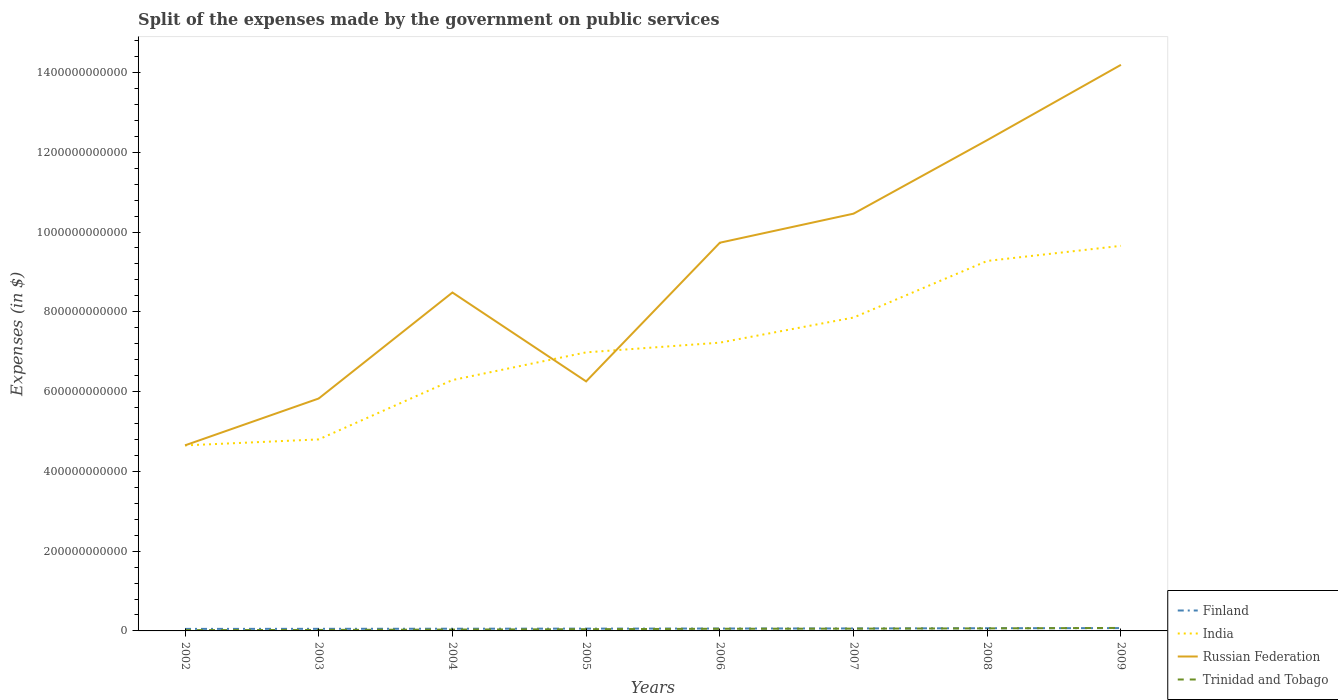Does the line corresponding to Finland intersect with the line corresponding to India?
Your response must be concise. No. Across all years, what is the maximum expenses made by the government on public services in Trinidad and Tobago?
Provide a succinct answer. 2.00e+09. What is the total expenses made by the government on public services in Trinidad and Tobago in the graph?
Your answer should be compact. -2.00e+09. What is the difference between the highest and the second highest expenses made by the government on public services in India?
Give a very brief answer. 5.00e+11. Is the expenses made by the government on public services in Trinidad and Tobago strictly greater than the expenses made by the government on public services in Russian Federation over the years?
Provide a short and direct response. Yes. How many lines are there?
Offer a terse response. 4. How many years are there in the graph?
Offer a terse response. 8. What is the difference between two consecutive major ticks on the Y-axis?
Your response must be concise. 2.00e+11. Where does the legend appear in the graph?
Offer a very short reply. Bottom right. What is the title of the graph?
Offer a terse response. Split of the expenses made by the government on public services. What is the label or title of the X-axis?
Your answer should be very brief. Years. What is the label or title of the Y-axis?
Your answer should be very brief. Expenses (in $). What is the Expenses (in $) in Finland in 2002?
Keep it short and to the point. 5.07e+09. What is the Expenses (in $) of India in 2002?
Offer a very short reply. 4.65e+11. What is the Expenses (in $) of Russian Federation in 2002?
Keep it short and to the point. 4.65e+11. What is the Expenses (in $) of Trinidad and Tobago in 2002?
Make the answer very short. 2.00e+09. What is the Expenses (in $) in Finland in 2003?
Offer a terse response. 5.26e+09. What is the Expenses (in $) in India in 2003?
Your response must be concise. 4.80e+11. What is the Expenses (in $) in Russian Federation in 2003?
Provide a succinct answer. 5.83e+11. What is the Expenses (in $) of Trinidad and Tobago in 2003?
Your response must be concise. 2.47e+09. What is the Expenses (in $) of Finland in 2004?
Keep it short and to the point. 5.52e+09. What is the Expenses (in $) of India in 2004?
Provide a succinct answer. 6.29e+11. What is the Expenses (in $) of Russian Federation in 2004?
Your response must be concise. 8.48e+11. What is the Expenses (in $) of Trinidad and Tobago in 2004?
Ensure brevity in your answer.  3.42e+09. What is the Expenses (in $) in Finland in 2005?
Give a very brief answer. 5.77e+09. What is the Expenses (in $) of India in 2005?
Offer a very short reply. 6.98e+11. What is the Expenses (in $) of Russian Federation in 2005?
Your response must be concise. 6.26e+11. What is the Expenses (in $) of Trinidad and Tobago in 2005?
Your answer should be compact. 4.34e+09. What is the Expenses (in $) in Finland in 2006?
Your answer should be very brief. 6.00e+09. What is the Expenses (in $) in India in 2006?
Your answer should be very brief. 7.23e+11. What is the Expenses (in $) of Russian Federation in 2006?
Give a very brief answer. 9.73e+11. What is the Expenses (in $) in Trinidad and Tobago in 2006?
Keep it short and to the point. 5.42e+09. What is the Expenses (in $) in Finland in 2007?
Keep it short and to the point. 6.23e+09. What is the Expenses (in $) in India in 2007?
Give a very brief answer. 7.86e+11. What is the Expenses (in $) of Russian Federation in 2007?
Make the answer very short. 1.05e+12. What is the Expenses (in $) of Trinidad and Tobago in 2007?
Your answer should be very brief. 5.72e+09. What is the Expenses (in $) in Finland in 2008?
Give a very brief answer. 6.73e+09. What is the Expenses (in $) in India in 2008?
Give a very brief answer. 9.28e+11. What is the Expenses (in $) in Russian Federation in 2008?
Ensure brevity in your answer.  1.23e+12. What is the Expenses (in $) of Trinidad and Tobago in 2008?
Provide a short and direct response. 6.37e+09. What is the Expenses (in $) in Finland in 2009?
Offer a very short reply. 7.08e+09. What is the Expenses (in $) in India in 2009?
Give a very brief answer. 9.65e+11. What is the Expenses (in $) of Russian Federation in 2009?
Your answer should be compact. 1.42e+12. What is the Expenses (in $) in Trinidad and Tobago in 2009?
Provide a succinct answer. 7.48e+09. Across all years, what is the maximum Expenses (in $) of Finland?
Provide a succinct answer. 7.08e+09. Across all years, what is the maximum Expenses (in $) in India?
Offer a very short reply. 9.65e+11. Across all years, what is the maximum Expenses (in $) of Russian Federation?
Your answer should be compact. 1.42e+12. Across all years, what is the maximum Expenses (in $) in Trinidad and Tobago?
Make the answer very short. 7.48e+09. Across all years, what is the minimum Expenses (in $) in Finland?
Offer a very short reply. 5.07e+09. Across all years, what is the minimum Expenses (in $) of India?
Ensure brevity in your answer.  4.65e+11. Across all years, what is the minimum Expenses (in $) of Russian Federation?
Offer a very short reply. 4.65e+11. Across all years, what is the minimum Expenses (in $) in Trinidad and Tobago?
Offer a terse response. 2.00e+09. What is the total Expenses (in $) of Finland in the graph?
Keep it short and to the point. 4.77e+1. What is the total Expenses (in $) in India in the graph?
Your answer should be compact. 5.67e+12. What is the total Expenses (in $) of Russian Federation in the graph?
Offer a very short reply. 7.19e+12. What is the total Expenses (in $) in Trinidad and Tobago in the graph?
Your answer should be compact. 3.72e+1. What is the difference between the Expenses (in $) in Finland in 2002 and that in 2003?
Give a very brief answer. -1.97e+08. What is the difference between the Expenses (in $) of India in 2002 and that in 2003?
Your answer should be very brief. -1.50e+1. What is the difference between the Expenses (in $) of Russian Federation in 2002 and that in 2003?
Offer a terse response. -1.17e+11. What is the difference between the Expenses (in $) of Trinidad and Tobago in 2002 and that in 2003?
Your response must be concise. -4.67e+08. What is the difference between the Expenses (in $) in Finland in 2002 and that in 2004?
Give a very brief answer. -4.53e+08. What is the difference between the Expenses (in $) in India in 2002 and that in 2004?
Your answer should be very brief. -1.64e+11. What is the difference between the Expenses (in $) of Russian Federation in 2002 and that in 2004?
Offer a very short reply. -3.83e+11. What is the difference between the Expenses (in $) of Trinidad and Tobago in 2002 and that in 2004?
Keep it short and to the point. -1.41e+09. What is the difference between the Expenses (in $) of Finland in 2002 and that in 2005?
Your response must be concise. -7.02e+08. What is the difference between the Expenses (in $) in India in 2002 and that in 2005?
Provide a succinct answer. -2.33e+11. What is the difference between the Expenses (in $) in Russian Federation in 2002 and that in 2005?
Give a very brief answer. -1.60e+11. What is the difference between the Expenses (in $) in Trinidad and Tobago in 2002 and that in 2005?
Offer a terse response. -2.33e+09. What is the difference between the Expenses (in $) of Finland in 2002 and that in 2006?
Keep it short and to the point. -9.37e+08. What is the difference between the Expenses (in $) in India in 2002 and that in 2006?
Keep it short and to the point. -2.58e+11. What is the difference between the Expenses (in $) of Russian Federation in 2002 and that in 2006?
Keep it short and to the point. -5.08e+11. What is the difference between the Expenses (in $) in Trinidad and Tobago in 2002 and that in 2006?
Ensure brevity in your answer.  -3.42e+09. What is the difference between the Expenses (in $) in Finland in 2002 and that in 2007?
Offer a very short reply. -1.16e+09. What is the difference between the Expenses (in $) of India in 2002 and that in 2007?
Ensure brevity in your answer.  -3.21e+11. What is the difference between the Expenses (in $) of Russian Federation in 2002 and that in 2007?
Provide a short and direct response. -5.81e+11. What is the difference between the Expenses (in $) of Trinidad and Tobago in 2002 and that in 2007?
Make the answer very short. -3.72e+09. What is the difference between the Expenses (in $) in Finland in 2002 and that in 2008?
Your answer should be compact. -1.67e+09. What is the difference between the Expenses (in $) in India in 2002 and that in 2008?
Provide a short and direct response. -4.62e+11. What is the difference between the Expenses (in $) in Russian Federation in 2002 and that in 2008?
Make the answer very short. -7.65e+11. What is the difference between the Expenses (in $) in Trinidad and Tobago in 2002 and that in 2008?
Your answer should be very brief. -4.36e+09. What is the difference between the Expenses (in $) in Finland in 2002 and that in 2009?
Your response must be concise. -2.01e+09. What is the difference between the Expenses (in $) in India in 2002 and that in 2009?
Your answer should be compact. -5.00e+11. What is the difference between the Expenses (in $) of Russian Federation in 2002 and that in 2009?
Provide a succinct answer. -9.54e+11. What is the difference between the Expenses (in $) in Trinidad and Tobago in 2002 and that in 2009?
Your answer should be compact. -5.48e+09. What is the difference between the Expenses (in $) of Finland in 2003 and that in 2004?
Your answer should be very brief. -2.56e+08. What is the difference between the Expenses (in $) of India in 2003 and that in 2004?
Give a very brief answer. -1.49e+11. What is the difference between the Expenses (in $) in Russian Federation in 2003 and that in 2004?
Make the answer very short. -2.66e+11. What is the difference between the Expenses (in $) of Trinidad and Tobago in 2003 and that in 2004?
Provide a succinct answer. -9.46e+08. What is the difference between the Expenses (in $) of Finland in 2003 and that in 2005?
Make the answer very short. -5.05e+08. What is the difference between the Expenses (in $) in India in 2003 and that in 2005?
Offer a terse response. -2.18e+11. What is the difference between the Expenses (in $) of Russian Federation in 2003 and that in 2005?
Your answer should be very brief. -4.29e+1. What is the difference between the Expenses (in $) of Trinidad and Tobago in 2003 and that in 2005?
Ensure brevity in your answer.  -1.87e+09. What is the difference between the Expenses (in $) in Finland in 2003 and that in 2006?
Offer a very short reply. -7.40e+08. What is the difference between the Expenses (in $) in India in 2003 and that in 2006?
Your answer should be compact. -2.43e+11. What is the difference between the Expenses (in $) in Russian Federation in 2003 and that in 2006?
Offer a terse response. -3.91e+11. What is the difference between the Expenses (in $) in Trinidad and Tobago in 2003 and that in 2006?
Provide a succinct answer. -2.95e+09. What is the difference between the Expenses (in $) of Finland in 2003 and that in 2007?
Your answer should be very brief. -9.62e+08. What is the difference between the Expenses (in $) of India in 2003 and that in 2007?
Give a very brief answer. -3.05e+11. What is the difference between the Expenses (in $) in Russian Federation in 2003 and that in 2007?
Ensure brevity in your answer.  -4.63e+11. What is the difference between the Expenses (in $) in Trinidad and Tobago in 2003 and that in 2007?
Your answer should be compact. -3.25e+09. What is the difference between the Expenses (in $) of Finland in 2003 and that in 2008?
Offer a terse response. -1.47e+09. What is the difference between the Expenses (in $) in India in 2003 and that in 2008?
Your answer should be very brief. -4.47e+11. What is the difference between the Expenses (in $) of Russian Federation in 2003 and that in 2008?
Your answer should be very brief. -6.48e+11. What is the difference between the Expenses (in $) of Trinidad and Tobago in 2003 and that in 2008?
Ensure brevity in your answer.  -3.90e+09. What is the difference between the Expenses (in $) of Finland in 2003 and that in 2009?
Your answer should be very brief. -1.81e+09. What is the difference between the Expenses (in $) of India in 2003 and that in 2009?
Your response must be concise. -4.85e+11. What is the difference between the Expenses (in $) of Russian Federation in 2003 and that in 2009?
Ensure brevity in your answer.  -8.36e+11. What is the difference between the Expenses (in $) of Trinidad and Tobago in 2003 and that in 2009?
Your answer should be compact. -5.01e+09. What is the difference between the Expenses (in $) in Finland in 2004 and that in 2005?
Give a very brief answer. -2.49e+08. What is the difference between the Expenses (in $) of India in 2004 and that in 2005?
Your response must be concise. -6.94e+1. What is the difference between the Expenses (in $) of Russian Federation in 2004 and that in 2005?
Offer a terse response. 2.23e+11. What is the difference between the Expenses (in $) of Trinidad and Tobago in 2004 and that in 2005?
Provide a short and direct response. -9.19e+08. What is the difference between the Expenses (in $) in Finland in 2004 and that in 2006?
Your response must be concise. -4.84e+08. What is the difference between the Expenses (in $) of India in 2004 and that in 2006?
Make the answer very short. -9.38e+1. What is the difference between the Expenses (in $) of Russian Federation in 2004 and that in 2006?
Your answer should be compact. -1.25e+11. What is the difference between the Expenses (in $) of Trinidad and Tobago in 2004 and that in 2006?
Your answer should be compact. -2.00e+09. What is the difference between the Expenses (in $) in Finland in 2004 and that in 2007?
Ensure brevity in your answer.  -7.06e+08. What is the difference between the Expenses (in $) of India in 2004 and that in 2007?
Your answer should be compact. -1.57e+11. What is the difference between the Expenses (in $) of Russian Federation in 2004 and that in 2007?
Your answer should be compact. -1.98e+11. What is the difference between the Expenses (in $) in Trinidad and Tobago in 2004 and that in 2007?
Give a very brief answer. -2.30e+09. What is the difference between the Expenses (in $) in Finland in 2004 and that in 2008?
Provide a succinct answer. -1.21e+09. What is the difference between the Expenses (in $) in India in 2004 and that in 2008?
Give a very brief answer. -2.99e+11. What is the difference between the Expenses (in $) in Russian Federation in 2004 and that in 2008?
Ensure brevity in your answer.  -3.82e+11. What is the difference between the Expenses (in $) in Trinidad and Tobago in 2004 and that in 2008?
Your answer should be very brief. -2.95e+09. What is the difference between the Expenses (in $) in Finland in 2004 and that in 2009?
Ensure brevity in your answer.  -1.56e+09. What is the difference between the Expenses (in $) of India in 2004 and that in 2009?
Your answer should be compact. -3.36e+11. What is the difference between the Expenses (in $) in Russian Federation in 2004 and that in 2009?
Your response must be concise. -5.71e+11. What is the difference between the Expenses (in $) in Trinidad and Tobago in 2004 and that in 2009?
Your answer should be very brief. -4.07e+09. What is the difference between the Expenses (in $) of Finland in 2005 and that in 2006?
Give a very brief answer. -2.35e+08. What is the difference between the Expenses (in $) of India in 2005 and that in 2006?
Your answer should be very brief. -2.43e+1. What is the difference between the Expenses (in $) of Russian Federation in 2005 and that in 2006?
Keep it short and to the point. -3.48e+11. What is the difference between the Expenses (in $) of Trinidad and Tobago in 2005 and that in 2006?
Give a very brief answer. -1.08e+09. What is the difference between the Expenses (in $) in Finland in 2005 and that in 2007?
Provide a succinct answer. -4.57e+08. What is the difference between the Expenses (in $) in India in 2005 and that in 2007?
Make the answer very short. -8.73e+1. What is the difference between the Expenses (in $) of Russian Federation in 2005 and that in 2007?
Your response must be concise. -4.20e+11. What is the difference between the Expenses (in $) in Trinidad and Tobago in 2005 and that in 2007?
Keep it short and to the point. -1.38e+09. What is the difference between the Expenses (in $) of Finland in 2005 and that in 2008?
Ensure brevity in your answer.  -9.64e+08. What is the difference between the Expenses (in $) in India in 2005 and that in 2008?
Your answer should be very brief. -2.29e+11. What is the difference between the Expenses (in $) in Russian Federation in 2005 and that in 2008?
Offer a terse response. -6.05e+11. What is the difference between the Expenses (in $) of Trinidad and Tobago in 2005 and that in 2008?
Your answer should be compact. -2.03e+09. What is the difference between the Expenses (in $) of Finland in 2005 and that in 2009?
Give a very brief answer. -1.31e+09. What is the difference between the Expenses (in $) in India in 2005 and that in 2009?
Provide a succinct answer. -2.67e+11. What is the difference between the Expenses (in $) of Russian Federation in 2005 and that in 2009?
Offer a very short reply. -7.94e+11. What is the difference between the Expenses (in $) of Trinidad and Tobago in 2005 and that in 2009?
Your answer should be very brief. -3.15e+09. What is the difference between the Expenses (in $) of Finland in 2006 and that in 2007?
Make the answer very short. -2.22e+08. What is the difference between the Expenses (in $) in India in 2006 and that in 2007?
Your answer should be compact. -6.29e+1. What is the difference between the Expenses (in $) of Russian Federation in 2006 and that in 2007?
Your answer should be very brief. -7.28e+1. What is the difference between the Expenses (in $) in Trinidad and Tobago in 2006 and that in 2007?
Provide a succinct answer. -3.00e+08. What is the difference between the Expenses (in $) in Finland in 2006 and that in 2008?
Give a very brief answer. -7.29e+08. What is the difference between the Expenses (in $) in India in 2006 and that in 2008?
Provide a succinct answer. -2.05e+11. What is the difference between the Expenses (in $) of Russian Federation in 2006 and that in 2008?
Offer a terse response. -2.57e+11. What is the difference between the Expenses (in $) of Trinidad and Tobago in 2006 and that in 2008?
Provide a succinct answer. -9.46e+08. What is the difference between the Expenses (in $) of Finland in 2006 and that in 2009?
Give a very brief answer. -1.07e+09. What is the difference between the Expenses (in $) of India in 2006 and that in 2009?
Make the answer very short. -2.43e+11. What is the difference between the Expenses (in $) in Russian Federation in 2006 and that in 2009?
Make the answer very short. -4.46e+11. What is the difference between the Expenses (in $) of Trinidad and Tobago in 2006 and that in 2009?
Your answer should be compact. -2.06e+09. What is the difference between the Expenses (in $) in Finland in 2007 and that in 2008?
Give a very brief answer. -5.07e+08. What is the difference between the Expenses (in $) in India in 2007 and that in 2008?
Offer a very short reply. -1.42e+11. What is the difference between the Expenses (in $) in Russian Federation in 2007 and that in 2008?
Provide a succinct answer. -1.84e+11. What is the difference between the Expenses (in $) in Trinidad and Tobago in 2007 and that in 2008?
Keep it short and to the point. -6.47e+08. What is the difference between the Expenses (in $) of Finland in 2007 and that in 2009?
Provide a succinct answer. -8.49e+08. What is the difference between the Expenses (in $) in India in 2007 and that in 2009?
Give a very brief answer. -1.80e+11. What is the difference between the Expenses (in $) of Russian Federation in 2007 and that in 2009?
Your answer should be very brief. -3.73e+11. What is the difference between the Expenses (in $) of Trinidad and Tobago in 2007 and that in 2009?
Keep it short and to the point. -1.76e+09. What is the difference between the Expenses (in $) in Finland in 2008 and that in 2009?
Provide a short and direct response. -3.42e+08. What is the difference between the Expenses (in $) in India in 2008 and that in 2009?
Give a very brief answer. -3.78e+1. What is the difference between the Expenses (in $) of Russian Federation in 2008 and that in 2009?
Offer a very short reply. -1.89e+11. What is the difference between the Expenses (in $) of Trinidad and Tobago in 2008 and that in 2009?
Make the answer very short. -1.12e+09. What is the difference between the Expenses (in $) of Finland in 2002 and the Expenses (in $) of India in 2003?
Provide a short and direct response. -4.75e+11. What is the difference between the Expenses (in $) of Finland in 2002 and the Expenses (in $) of Russian Federation in 2003?
Provide a short and direct response. -5.78e+11. What is the difference between the Expenses (in $) of Finland in 2002 and the Expenses (in $) of Trinidad and Tobago in 2003?
Offer a terse response. 2.60e+09. What is the difference between the Expenses (in $) of India in 2002 and the Expenses (in $) of Russian Federation in 2003?
Offer a terse response. -1.18e+11. What is the difference between the Expenses (in $) of India in 2002 and the Expenses (in $) of Trinidad and Tobago in 2003?
Ensure brevity in your answer.  4.63e+11. What is the difference between the Expenses (in $) in Russian Federation in 2002 and the Expenses (in $) in Trinidad and Tobago in 2003?
Ensure brevity in your answer.  4.63e+11. What is the difference between the Expenses (in $) in Finland in 2002 and the Expenses (in $) in India in 2004?
Offer a terse response. -6.24e+11. What is the difference between the Expenses (in $) of Finland in 2002 and the Expenses (in $) of Russian Federation in 2004?
Provide a short and direct response. -8.43e+11. What is the difference between the Expenses (in $) in Finland in 2002 and the Expenses (in $) in Trinidad and Tobago in 2004?
Keep it short and to the point. 1.65e+09. What is the difference between the Expenses (in $) of India in 2002 and the Expenses (in $) of Russian Federation in 2004?
Offer a terse response. -3.83e+11. What is the difference between the Expenses (in $) in India in 2002 and the Expenses (in $) in Trinidad and Tobago in 2004?
Your answer should be compact. 4.62e+11. What is the difference between the Expenses (in $) of Russian Federation in 2002 and the Expenses (in $) of Trinidad and Tobago in 2004?
Provide a succinct answer. 4.62e+11. What is the difference between the Expenses (in $) in Finland in 2002 and the Expenses (in $) in India in 2005?
Provide a succinct answer. -6.93e+11. What is the difference between the Expenses (in $) in Finland in 2002 and the Expenses (in $) in Russian Federation in 2005?
Your response must be concise. -6.20e+11. What is the difference between the Expenses (in $) in Finland in 2002 and the Expenses (in $) in Trinidad and Tobago in 2005?
Provide a short and direct response. 7.31e+08. What is the difference between the Expenses (in $) of India in 2002 and the Expenses (in $) of Russian Federation in 2005?
Offer a very short reply. -1.60e+11. What is the difference between the Expenses (in $) in India in 2002 and the Expenses (in $) in Trinidad and Tobago in 2005?
Provide a succinct answer. 4.61e+11. What is the difference between the Expenses (in $) in Russian Federation in 2002 and the Expenses (in $) in Trinidad and Tobago in 2005?
Ensure brevity in your answer.  4.61e+11. What is the difference between the Expenses (in $) in Finland in 2002 and the Expenses (in $) in India in 2006?
Give a very brief answer. -7.18e+11. What is the difference between the Expenses (in $) of Finland in 2002 and the Expenses (in $) of Russian Federation in 2006?
Offer a terse response. -9.68e+11. What is the difference between the Expenses (in $) of Finland in 2002 and the Expenses (in $) of Trinidad and Tobago in 2006?
Give a very brief answer. -3.52e+08. What is the difference between the Expenses (in $) of India in 2002 and the Expenses (in $) of Russian Federation in 2006?
Provide a succinct answer. -5.08e+11. What is the difference between the Expenses (in $) of India in 2002 and the Expenses (in $) of Trinidad and Tobago in 2006?
Offer a terse response. 4.60e+11. What is the difference between the Expenses (in $) in Russian Federation in 2002 and the Expenses (in $) in Trinidad and Tobago in 2006?
Make the answer very short. 4.60e+11. What is the difference between the Expenses (in $) of Finland in 2002 and the Expenses (in $) of India in 2007?
Offer a terse response. -7.81e+11. What is the difference between the Expenses (in $) in Finland in 2002 and the Expenses (in $) in Russian Federation in 2007?
Give a very brief answer. -1.04e+12. What is the difference between the Expenses (in $) of Finland in 2002 and the Expenses (in $) of Trinidad and Tobago in 2007?
Your response must be concise. -6.52e+08. What is the difference between the Expenses (in $) in India in 2002 and the Expenses (in $) in Russian Federation in 2007?
Your answer should be very brief. -5.81e+11. What is the difference between the Expenses (in $) in India in 2002 and the Expenses (in $) in Trinidad and Tobago in 2007?
Make the answer very short. 4.59e+11. What is the difference between the Expenses (in $) in Russian Federation in 2002 and the Expenses (in $) in Trinidad and Tobago in 2007?
Make the answer very short. 4.59e+11. What is the difference between the Expenses (in $) of Finland in 2002 and the Expenses (in $) of India in 2008?
Make the answer very short. -9.22e+11. What is the difference between the Expenses (in $) of Finland in 2002 and the Expenses (in $) of Russian Federation in 2008?
Offer a very short reply. -1.23e+12. What is the difference between the Expenses (in $) of Finland in 2002 and the Expenses (in $) of Trinidad and Tobago in 2008?
Ensure brevity in your answer.  -1.30e+09. What is the difference between the Expenses (in $) in India in 2002 and the Expenses (in $) in Russian Federation in 2008?
Keep it short and to the point. -7.65e+11. What is the difference between the Expenses (in $) of India in 2002 and the Expenses (in $) of Trinidad and Tobago in 2008?
Give a very brief answer. 4.59e+11. What is the difference between the Expenses (in $) of Russian Federation in 2002 and the Expenses (in $) of Trinidad and Tobago in 2008?
Give a very brief answer. 4.59e+11. What is the difference between the Expenses (in $) of Finland in 2002 and the Expenses (in $) of India in 2009?
Your response must be concise. -9.60e+11. What is the difference between the Expenses (in $) in Finland in 2002 and the Expenses (in $) in Russian Federation in 2009?
Provide a succinct answer. -1.41e+12. What is the difference between the Expenses (in $) in Finland in 2002 and the Expenses (in $) in Trinidad and Tobago in 2009?
Offer a very short reply. -2.42e+09. What is the difference between the Expenses (in $) in India in 2002 and the Expenses (in $) in Russian Federation in 2009?
Your answer should be very brief. -9.54e+11. What is the difference between the Expenses (in $) in India in 2002 and the Expenses (in $) in Trinidad and Tobago in 2009?
Your answer should be very brief. 4.58e+11. What is the difference between the Expenses (in $) of Russian Federation in 2002 and the Expenses (in $) of Trinidad and Tobago in 2009?
Offer a very short reply. 4.58e+11. What is the difference between the Expenses (in $) of Finland in 2003 and the Expenses (in $) of India in 2004?
Your answer should be very brief. -6.24e+11. What is the difference between the Expenses (in $) of Finland in 2003 and the Expenses (in $) of Russian Federation in 2004?
Your answer should be very brief. -8.43e+11. What is the difference between the Expenses (in $) of Finland in 2003 and the Expenses (in $) of Trinidad and Tobago in 2004?
Ensure brevity in your answer.  1.85e+09. What is the difference between the Expenses (in $) of India in 2003 and the Expenses (in $) of Russian Federation in 2004?
Your response must be concise. -3.68e+11. What is the difference between the Expenses (in $) in India in 2003 and the Expenses (in $) in Trinidad and Tobago in 2004?
Your answer should be very brief. 4.77e+11. What is the difference between the Expenses (in $) of Russian Federation in 2003 and the Expenses (in $) of Trinidad and Tobago in 2004?
Offer a very short reply. 5.79e+11. What is the difference between the Expenses (in $) of Finland in 2003 and the Expenses (in $) of India in 2005?
Give a very brief answer. -6.93e+11. What is the difference between the Expenses (in $) of Finland in 2003 and the Expenses (in $) of Russian Federation in 2005?
Ensure brevity in your answer.  -6.20e+11. What is the difference between the Expenses (in $) in Finland in 2003 and the Expenses (in $) in Trinidad and Tobago in 2005?
Offer a terse response. 9.28e+08. What is the difference between the Expenses (in $) of India in 2003 and the Expenses (in $) of Russian Federation in 2005?
Provide a short and direct response. -1.45e+11. What is the difference between the Expenses (in $) of India in 2003 and the Expenses (in $) of Trinidad and Tobago in 2005?
Offer a terse response. 4.76e+11. What is the difference between the Expenses (in $) of Russian Federation in 2003 and the Expenses (in $) of Trinidad and Tobago in 2005?
Give a very brief answer. 5.78e+11. What is the difference between the Expenses (in $) of Finland in 2003 and the Expenses (in $) of India in 2006?
Ensure brevity in your answer.  -7.17e+11. What is the difference between the Expenses (in $) of Finland in 2003 and the Expenses (in $) of Russian Federation in 2006?
Offer a terse response. -9.68e+11. What is the difference between the Expenses (in $) in Finland in 2003 and the Expenses (in $) in Trinidad and Tobago in 2006?
Offer a terse response. -1.56e+08. What is the difference between the Expenses (in $) in India in 2003 and the Expenses (in $) in Russian Federation in 2006?
Ensure brevity in your answer.  -4.93e+11. What is the difference between the Expenses (in $) of India in 2003 and the Expenses (in $) of Trinidad and Tobago in 2006?
Offer a very short reply. 4.75e+11. What is the difference between the Expenses (in $) of Russian Federation in 2003 and the Expenses (in $) of Trinidad and Tobago in 2006?
Your answer should be compact. 5.77e+11. What is the difference between the Expenses (in $) of Finland in 2003 and the Expenses (in $) of India in 2007?
Ensure brevity in your answer.  -7.80e+11. What is the difference between the Expenses (in $) of Finland in 2003 and the Expenses (in $) of Russian Federation in 2007?
Offer a very short reply. -1.04e+12. What is the difference between the Expenses (in $) of Finland in 2003 and the Expenses (in $) of Trinidad and Tobago in 2007?
Give a very brief answer. -4.55e+08. What is the difference between the Expenses (in $) in India in 2003 and the Expenses (in $) in Russian Federation in 2007?
Offer a very short reply. -5.66e+11. What is the difference between the Expenses (in $) in India in 2003 and the Expenses (in $) in Trinidad and Tobago in 2007?
Your answer should be very brief. 4.74e+11. What is the difference between the Expenses (in $) in Russian Federation in 2003 and the Expenses (in $) in Trinidad and Tobago in 2007?
Give a very brief answer. 5.77e+11. What is the difference between the Expenses (in $) in Finland in 2003 and the Expenses (in $) in India in 2008?
Provide a short and direct response. -9.22e+11. What is the difference between the Expenses (in $) in Finland in 2003 and the Expenses (in $) in Russian Federation in 2008?
Offer a very short reply. -1.23e+12. What is the difference between the Expenses (in $) in Finland in 2003 and the Expenses (in $) in Trinidad and Tobago in 2008?
Offer a very short reply. -1.10e+09. What is the difference between the Expenses (in $) in India in 2003 and the Expenses (in $) in Russian Federation in 2008?
Your response must be concise. -7.50e+11. What is the difference between the Expenses (in $) of India in 2003 and the Expenses (in $) of Trinidad and Tobago in 2008?
Make the answer very short. 4.74e+11. What is the difference between the Expenses (in $) in Russian Federation in 2003 and the Expenses (in $) in Trinidad and Tobago in 2008?
Offer a terse response. 5.76e+11. What is the difference between the Expenses (in $) in Finland in 2003 and the Expenses (in $) in India in 2009?
Make the answer very short. -9.60e+11. What is the difference between the Expenses (in $) of Finland in 2003 and the Expenses (in $) of Russian Federation in 2009?
Provide a short and direct response. -1.41e+12. What is the difference between the Expenses (in $) of Finland in 2003 and the Expenses (in $) of Trinidad and Tobago in 2009?
Provide a succinct answer. -2.22e+09. What is the difference between the Expenses (in $) of India in 2003 and the Expenses (in $) of Russian Federation in 2009?
Make the answer very short. -9.39e+11. What is the difference between the Expenses (in $) in India in 2003 and the Expenses (in $) in Trinidad and Tobago in 2009?
Your answer should be compact. 4.73e+11. What is the difference between the Expenses (in $) of Russian Federation in 2003 and the Expenses (in $) of Trinidad and Tobago in 2009?
Provide a succinct answer. 5.75e+11. What is the difference between the Expenses (in $) in Finland in 2004 and the Expenses (in $) in India in 2005?
Your answer should be very brief. -6.93e+11. What is the difference between the Expenses (in $) of Finland in 2004 and the Expenses (in $) of Russian Federation in 2005?
Provide a succinct answer. -6.20e+11. What is the difference between the Expenses (in $) of Finland in 2004 and the Expenses (in $) of Trinidad and Tobago in 2005?
Give a very brief answer. 1.18e+09. What is the difference between the Expenses (in $) in India in 2004 and the Expenses (in $) in Russian Federation in 2005?
Make the answer very short. 3.33e+09. What is the difference between the Expenses (in $) in India in 2004 and the Expenses (in $) in Trinidad and Tobago in 2005?
Provide a short and direct response. 6.25e+11. What is the difference between the Expenses (in $) in Russian Federation in 2004 and the Expenses (in $) in Trinidad and Tobago in 2005?
Ensure brevity in your answer.  8.44e+11. What is the difference between the Expenses (in $) of Finland in 2004 and the Expenses (in $) of India in 2006?
Provide a short and direct response. -7.17e+11. What is the difference between the Expenses (in $) of Finland in 2004 and the Expenses (in $) of Russian Federation in 2006?
Your response must be concise. -9.68e+11. What is the difference between the Expenses (in $) of Finland in 2004 and the Expenses (in $) of Trinidad and Tobago in 2006?
Offer a terse response. 1.00e+08. What is the difference between the Expenses (in $) of India in 2004 and the Expenses (in $) of Russian Federation in 2006?
Provide a succinct answer. -3.44e+11. What is the difference between the Expenses (in $) of India in 2004 and the Expenses (in $) of Trinidad and Tobago in 2006?
Provide a succinct answer. 6.23e+11. What is the difference between the Expenses (in $) of Russian Federation in 2004 and the Expenses (in $) of Trinidad and Tobago in 2006?
Keep it short and to the point. 8.43e+11. What is the difference between the Expenses (in $) of Finland in 2004 and the Expenses (in $) of India in 2007?
Offer a very short reply. -7.80e+11. What is the difference between the Expenses (in $) of Finland in 2004 and the Expenses (in $) of Russian Federation in 2007?
Offer a terse response. -1.04e+12. What is the difference between the Expenses (in $) of Finland in 2004 and the Expenses (in $) of Trinidad and Tobago in 2007?
Make the answer very short. -1.99e+08. What is the difference between the Expenses (in $) in India in 2004 and the Expenses (in $) in Russian Federation in 2007?
Keep it short and to the point. -4.17e+11. What is the difference between the Expenses (in $) of India in 2004 and the Expenses (in $) of Trinidad and Tobago in 2007?
Your answer should be very brief. 6.23e+11. What is the difference between the Expenses (in $) in Russian Federation in 2004 and the Expenses (in $) in Trinidad and Tobago in 2007?
Make the answer very short. 8.43e+11. What is the difference between the Expenses (in $) in Finland in 2004 and the Expenses (in $) in India in 2008?
Your answer should be compact. -9.22e+11. What is the difference between the Expenses (in $) of Finland in 2004 and the Expenses (in $) of Russian Federation in 2008?
Make the answer very short. -1.22e+12. What is the difference between the Expenses (in $) in Finland in 2004 and the Expenses (in $) in Trinidad and Tobago in 2008?
Give a very brief answer. -8.46e+08. What is the difference between the Expenses (in $) of India in 2004 and the Expenses (in $) of Russian Federation in 2008?
Make the answer very short. -6.02e+11. What is the difference between the Expenses (in $) of India in 2004 and the Expenses (in $) of Trinidad and Tobago in 2008?
Give a very brief answer. 6.23e+11. What is the difference between the Expenses (in $) in Russian Federation in 2004 and the Expenses (in $) in Trinidad and Tobago in 2008?
Your answer should be compact. 8.42e+11. What is the difference between the Expenses (in $) in Finland in 2004 and the Expenses (in $) in India in 2009?
Provide a succinct answer. -9.60e+11. What is the difference between the Expenses (in $) of Finland in 2004 and the Expenses (in $) of Russian Federation in 2009?
Ensure brevity in your answer.  -1.41e+12. What is the difference between the Expenses (in $) of Finland in 2004 and the Expenses (in $) of Trinidad and Tobago in 2009?
Your response must be concise. -1.96e+09. What is the difference between the Expenses (in $) of India in 2004 and the Expenses (in $) of Russian Federation in 2009?
Offer a terse response. -7.90e+11. What is the difference between the Expenses (in $) of India in 2004 and the Expenses (in $) of Trinidad and Tobago in 2009?
Your answer should be very brief. 6.21e+11. What is the difference between the Expenses (in $) of Russian Federation in 2004 and the Expenses (in $) of Trinidad and Tobago in 2009?
Make the answer very short. 8.41e+11. What is the difference between the Expenses (in $) in Finland in 2005 and the Expenses (in $) in India in 2006?
Make the answer very short. -7.17e+11. What is the difference between the Expenses (in $) in Finland in 2005 and the Expenses (in $) in Russian Federation in 2006?
Make the answer very short. -9.67e+11. What is the difference between the Expenses (in $) in Finland in 2005 and the Expenses (in $) in Trinidad and Tobago in 2006?
Offer a very short reply. 3.50e+08. What is the difference between the Expenses (in $) of India in 2005 and the Expenses (in $) of Russian Federation in 2006?
Ensure brevity in your answer.  -2.75e+11. What is the difference between the Expenses (in $) of India in 2005 and the Expenses (in $) of Trinidad and Tobago in 2006?
Your response must be concise. 6.93e+11. What is the difference between the Expenses (in $) of Russian Federation in 2005 and the Expenses (in $) of Trinidad and Tobago in 2006?
Ensure brevity in your answer.  6.20e+11. What is the difference between the Expenses (in $) in Finland in 2005 and the Expenses (in $) in India in 2007?
Ensure brevity in your answer.  -7.80e+11. What is the difference between the Expenses (in $) of Finland in 2005 and the Expenses (in $) of Russian Federation in 2007?
Your response must be concise. -1.04e+12. What is the difference between the Expenses (in $) in Finland in 2005 and the Expenses (in $) in Trinidad and Tobago in 2007?
Ensure brevity in your answer.  4.98e+07. What is the difference between the Expenses (in $) in India in 2005 and the Expenses (in $) in Russian Federation in 2007?
Your answer should be very brief. -3.48e+11. What is the difference between the Expenses (in $) in India in 2005 and the Expenses (in $) in Trinidad and Tobago in 2007?
Give a very brief answer. 6.93e+11. What is the difference between the Expenses (in $) in Russian Federation in 2005 and the Expenses (in $) in Trinidad and Tobago in 2007?
Offer a terse response. 6.20e+11. What is the difference between the Expenses (in $) in Finland in 2005 and the Expenses (in $) in India in 2008?
Offer a terse response. -9.22e+11. What is the difference between the Expenses (in $) in Finland in 2005 and the Expenses (in $) in Russian Federation in 2008?
Your answer should be very brief. -1.22e+12. What is the difference between the Expenses (in $) of Finland in 2005 and the Expenses (in $) of Trinidad and Tobago in 2008?
Your answer should be compact. -5.97e+08. What is the difference between the Expenses (in $) in India in 2005 and the Expenses (in $) in Russian Federation in 2008?
Keep it short and to the point. -5.32e+11. What is the difference between the Expenses (in $) of India in 2005 and the Expenses (in $) of Trinidad and Tobago in 2008?
Your response must be concise. 6.92e+11. What is the difference between the Expenses (in $) in Russian Federation in 2005 and the Expenses (in $) in Trinidad and Tobago in 2008?
Provide a succinct answer. 6.19e+11. What is the difference between the Expenses (in $) of Finland in 2005 and the Expenses (in $) of India in 2009?
Your response must be concise. -9.60e+11. What is the difference between the Expenses (in $) in Finland in 2005 and the Expenses (in $) in Russian Federation in 2009?
Offer a terse response. -1.41e+12. What is the difference between the Expenses (in $) in Finland in 2005 and the Expenses (in $) in Trinidad and Tobago in 2009?
Your answer should be very brief. -1.71e+09. What is the difference between the Expenses (in $) in India in 2005 and the Expenses (in $) in Russian Federation in 2009?
Your response must be concise. -7.21e+11. What is the difference between the Expenses (in $) in India in 2005 and the Expenses (in $) in Trinidad and Tobago in 2009?
Offer a very short reply. 6.91e+11. What is the difference between the Expenses (in $) in Russian Federation in 2005 and the Expenses (in $) in Trinidad and Tobago in 2009?
Offer a very short reply. 6.18e+11. What is the difference between the Expenses (in $) of Finland in 2006 and the Expenses (in $) of India in 2007?
Make the answer very short. -7.80e+11. What is the difference between the Expenses (in $) in Finland in 2006 and the Expenses (in $) in Russian Federation in 2007?
Provide a succinct answer. -1.04e+12. What is the difference between the Expenses (in $) in Finland in 2006 and the Expenses (in $) in Trinidad and Tobago in 2007?
Make the answer very short. 2.85e+08. What is the difference between the Expenses (in $) of India in 2006 and the Expenses (in $) of Russian Federation in 2007?
Your response must be concise. -3.23e+11. What is the difference between the Expenses (in $) of India in 2006 and the Expenses (in $) of Trinidad and Tobago in 2007?
Your answer should be very brief. 7.17e+11. What is the difference between the Expenses (in $) in Russian Federation in 2006 and the Expenses (in $) in Trinidad and Tobago in 2007?
Provide a succinct answer. 9.67e+11. What is the difference between the Expenses (in $) of Finland in 2006 and the Expenses (in $) of India in 2008?
Give a very brief answer. -9.22e+11. What is the difference between the Expenses (in $) in Finland in 2006 and the Expenses (in $) in Russian Federation in 2008?
Give a very brief answer. -1.22e+12. What is the difference between the Expenses (in $) in Finland in 2006 and the Expenses (in $) in Trinidad and Tobago in 2008?
Your answer should be very brief. -3.62e+08. What is the difference between the Expenses (in $) in India in 2006 and the Expenses (in $) in Russian Federation in 2008?
Your response must be concise. -5.08e+11. What is the difference between the Expenses (in $) of India in 2006 and the Expenses (in $) of Trinidad and Tobago in 2008?
Offer a terse response. 7.16e+11. What is the difference between the Expenses (in $) in Russian Federation in 2006 and the Expenses (in $) in Trinidad and Tobago in 2008?
Your answer should be very brief. 9.67e+11. What is the difference between the Expenses (in $) of Finland in 2006 and the Expenses (in $) of India in 2009?
Ensure brevity in your answer.  -9.59e+11. What is the difference between the Expenses (in $) in Finland in 2006 and the Expenses (in $) in Russian Federation in 2009?
Your response must be concise. -1.41e+12. What is the difference between the Expenses (in $) of Finland in 2006 and the Expenses (in $) of Trinidad and Tobago in 2009?
Your answer should be compact. -1.48e+09. What is the difference between the Expenses (in $) of India in 2006 and the Expenses (in $) of Russian Federation in 2009?
Ensure brevity in your answer.  -6.96e+11. What is the difference between the Expenses (in $) of India in 2006 and the Expenses (in $) of Trinidad and Tobago in 2009?
Keep it short and to the point. 7.15e+11. What is the difference between the Expenses (in $) in Russian Federation in 2006 and the Expenses (in $) in Trinidad and Tobago in 2009?
Your answer should be very brief. 9.66e+11. What is the difference between the Expenses (in $) in Finland in 2007 and the Expenses (in $) in India in 2008?
Keep it short and to the point. -9.21e+11. What is the difference between the Expenses (in $) of Finland in 2007 and the Expenses (in $) of Russian Federation in 2008?
Your response must be concise. -1.22e+12. What is the difference between the Expenses (in $) of Finland in 2007 and the Expenses (in $) of Trinidad and Tobago in 2008?
Your answer should be very brief. -1.40e+08. What is the difference between the Expenses (in $) of India in 2007 and the Expenses (in $) of Russian Federation in 2008?
Your answer should be compact. -4.45e+11. What is the difference between the Expenses (in $) of India in 2007 and the Expenses (in $) of Trinidad and Tobago in 2008?
Offer a very short reply. 7.79e+11. What is the difference between the Expenses (in $) of Russian Federation in 2007 and the Expenses (in $) of Trinidad and Tobago in 2008?
Provide a succinct answer. 1.04e+12. What is the difference between the Expenses (in $) of Finland in 2007 and the Expenses (in $) of India in 2009?
Your answer should be compact. -9.59e+11. What is the difference between the Expenses (in $) in Finland in 2007 and the Expenses (in $) in Russian Federation in 2009?
Your response must be concise. -1.41e+12. What is the difference between the Expenses (in $) of Finland in 2007 and the Expenses (in $) of Trinidad and Tobago in 2009?
Offer a very short reply. -1.26e+09. What is the difference between the Expenses (in $) in India in 2007 and the Expenses (in $) in Russian Federation in 2009?
Provide a succinct answer. -6.34e+11. What is the difference between the Expenses (in $) of India in 2007 and the Expenses (in $) of Trinidad and Tobago in 2009?
Your answer should be very brief. 7.78e+11. What is the difference between the Expenses (in $) in Russian Federation in 2007 and the Expenses (in $) in Trinidad and Tobago in 2009?
Offer a very short reply. 1.04e+12. What is the difference between the Expenses (in $) in Finland in 2008 and the Expenses (in $) in India in 2009?
Keep it short and to the point. -9.59e+11. What is the difference between the Expenses (in $) in Finland in 2008 and the Expenses (in $) in Russian Federation in 2009?
Keep it short and to the point. -1.41e+12. What is the difference between the Expenses (in $) of Finland in 2008 and the Expenses (in $) of Trinidad and Tobago in 2009?
Offer a terse response. -7.51e+08. What is the difference between the Expenses (in $) of India in 2008 and the Expenses (in $) of Russian Federation in 2009?
Offer a very short reply. -4.92e+11. What is the difference between the Expenses (in $) in India in 2008 and the Expenses (in $) in Trinidad and Tobago in 2009?
Offer a very short reply. 9.20e+11. What is the difference between the Expenses (in $) in Russian Federation in 2008 and the Expenses (in $) in Trinidad and Tobago in 2009?
Keep it short and to the point. 1.22e+12. What is the average Expenses (in $) of Finland per year?
Your answer should be compact. 5.96e+09. What is the average Expenses (in $) of India per year?
Keep it short and to the point. 7.09e+11. What is the average Expenses (in $) in Russian Federation per year?
Your answer should be very brief. 8.99e+11. What is the average Expenses (in $) of Trinidad and Tobago per year?
Offer a terse response. 4.65e+09. In the year 2002, what is the difference between the Expenses (in $) in Finland and Expenses (in $) in India?
Provide a succinct answer. -4.60e+11. In the year 2002, what is the difference between the Expenses (in $) in Finland and Expenses (in $) in Russian Federation?
Make the answer very short. -4.60e+11. In the year 2002, what is the difference between the Expenses (in $) of Finland and Expenses (in $) of Trinidad and Tobago?
Your answer should be very brief. 3.06e+09. In the year 2002, what is the difference between the Expenses (in $) of India and Expenses (in $) of Russian Federation?
Provide a succinct answer. -1.11e+08. In the year 2002, what is the difference between the Expenses (in $) in India and Expenses (in $) in Trinidad and Tobago?
Your answer should be very brief. 4.63e+11. In the year 2002, what is the difference between the Expenses (in $) in Russian Federation and Expenses (in $) in Trinidad and Tobago?
Your answer should be very brief. 4.63e+11. In the year 2003, what is the difference between the Expenses (in $) in Finland and Expenses (in $) in India?
Offer a very short reply. -4.75e+11. In the year 2003, what is the difference between the Expenses (in $) of Finland and Expenses (in $) of Russian Federation?
Provide a short and direct response. -5.77e+11. In the year 2003, what is the difference between the Expenses (in $) in Finland and Expenses (in $) in Trinidad and Tobago?
Your response must be concise. 2.79e+09. In the year 2003, what is the difference between the Expenses (in $) of India and Expenses (in $) of Russian Federation?
Your answer should be compact. -1.03e+11. In the year 2003, what is the difference between the Expenses (in $) in India and Expenses (in $) in Trinidad and Tobago?
Ensure brevity in your answer.  4.78e+11. In the year 2003, what is the difference between the Expenses (in $) of Russian Federation and Expenses (in $) of Trinidad and Tobago?
Provide a short and direct response. 5.80e+11. In the year 2004, what is the difference between the Expenses (in $) of Finland and Expenses (in $) of India?
Offer a terse response. -6.23e+11. In the year 2004, what is the difference between the Expenses (in $) in Finland and Expenses (in $) in Russian Federation?
Make the answer very short. -8.43e+11. In the year 2004, what is the difference between the Expenses (in $) in Finland and Expenses (in $) in Trinidad and Tobago?
Give a very brief answer. 2.10e+09. In the year 2004, what is the difference between the Expenses (in $) of India and Expenses (in $) of Russian Federation?
Keep it short and to the point. -2.19e+11. In the year 2004, what is the difference between the Expenses (in $) in India and Expenses (in $) in Trinidad and Tobago?
Your answer should be compact. 6.25e+11. In the year 2004, what is the difference between the Expenses (in $) in Russian Federation and Expenses (in $) in Trinidad and Tobago?
Your answer should be compact. 8.45e+11. In the year 2005, what is the difference between the Expenses (in $) of Finland and Expenses (in $) of India?
Keep it short and to the point. -6.93e+11. In the year 2005, what is the difference between the Expenses (in $) of Finland and Expenses (in $) of Russian Federation?
Give a very brief answer. -6.20e+11. In the year 2005, what is the difference between the Expenses (in $) in Finland and Expenses (in $) in Trinidad and Tobago?
Provide a short and direct response. 1.43e+09. In the year 2005, what is the difference between the Expenses (in $) of India and Expenses (in $) of Russian Federation?
Provide a short and direct response. 7.28e+1. In the year 2005, what is the difference between the Expenses (in $) of India and Expenses (in $) of Trinidad and Tobago?
Ensure brevity in your answer.  6.94e+11. In the year 2005, what is the difference between the Expenses (in $) of Russian Federation and Expenses (in $) of Trinidad and Tobago?
Give a very brief answer. 6.21e+11. In the year 2006, what is the difference between the Expenses (in $) in Finland and Expenses (in $) in India?
Give a very brief answer. -7.17e+11. In the year 2006, what is the difference between the Expenses (in $) in Finland and Expenses (in $) in Russian Federation?
Your answer should be very brief. -9.67e+11. In the year 2006, what is the difference between the Expenses (in $) in Finland and Expenses (in $) in Trinidad and Tobago?
Give a very brief answer. 5.84e+08. In the year 2006, what is the difference between the Expenses (in $) in India and Expenses (in $) in Russian Federation?
Give a very brief answer. -2.51e+11. In the year 2006, what is the difference between the Expenses (in $) in India and Expenses (in $) in Trinidad and Tobago?
Provide a short and direct response. 7.17e+11. In the year 2006, what is the difference between the Expenses (in $) of Russian Federation and Expenses (in $) of Trinidad and Tobago?
Provide a succinct answer. 9.68e+11. In the year 2007, what is the difference between the Expenses (in $) in Finland and Expenses (in $) in India?
Give a very brief answer. -7.79e+11. In the year 2007, what is the difference between the Expenses (in $) of Finland and Expenses (in $) of Russian Federation?
Provide a succinct answer. -1.04e+12. In the year 2007, what is the difference between the Expenses (in $) in Finland and Expenses (in $) in Trinidad and Tobago?
Provide a succinct answer. 5.07e+08. In the year 2007, what is the difference between the Expenses (in $) in India and Expenses (in $) in Russian Federation?
Keep it short and to the point. -2.60e+11. In the year 2007, what is the difference between the Expenses (in $) of India and Expenses (in $) of Trinidad and Tobago?
Ensure brevity in your answer.  7.80e+11. In the year 2007, what is the difference between the Expenses (in $) of Russian Federation and Expenses (in $) of Trinidad and Tobago?
Offer a very short reply. 1.04e+12. In the year 2008, what is the difference between the Expenses (in $) in Finland and Expenses (in $) in India?
Your answer should be very brief. -9.21e+11. In the year 2008, what is the difference between the Expenses (in $) of Finland and Expenses (in $) of Russian Federation?
Provide a succinct answer. -1.22e+12. In the year 2008, what is the difference between the Expenses (in $) of Finland and Expenses (in $) of Trinidad and Tobago?
Your answer should be compact. 3.67e+08. In the year 2008, what is the difference between the Expenses (in $) of India and Expenses (in $) of Russian Federation?
Provide a succinct answer. -3.03e+11. In the year 2008, what is the difference between the Expenses (in $) in India and Expenses (in $) in Trinidad and Tobago?
Provide a short and direct response. 9.21e+11. In the year 2008, what is the difference between the Expenses (in $) of Russian Federation and Expenses (in $) of Trinidad and Tobago?
Your answer should be compact. 1.22e+12. In the year 2009, what is the difference between the Expenses (in $) in Finland and Expenses (in $) in India?
Make the answer very short. -9.58e+11. In the year 2009, what is the difference between the Expenses (in $) of Finland and Expenses (in $) of Russian Federation?
Your response must be concise. -1.41e+12. In the year 2009, what is the difference between the Expenses (in $) in Finland and Expenses (in $) in Trinidad and Tobago?
Give a very brief answer. -4.09e+08. In the year 2009, what is the difference between the Expenses (in $) in India and Expenses (in $) in Russian Federation?
Offer a very short reply. -4.54e+11. In the year 2009, what is the difference between the Expenses (in $) in India and Expenses (in $) in Trinidad and Tobago?
Provide a short and direct response. 9.58e+11. In the year 2009, what is the difference between the Expenses (in $) in Russian Federation and Expenses (in $) in Trinidad and Tobago?
Offer a very short reply. 1.41e+12. What is the ratio of the Expenses (in $) in Finland in 2002 to that in 2003?
Your answer should be very brief. 0.96. What is the ratio of the Expenses (in $) of India in 2002 to that in 2003?
Offer a very short reply. 0.97. What is the ratio of the Expenses (in $) of Russian Federation in 2002 to that in 2003?
Provide a succinct answer. 0.8. What is the ratio of the Expenses (in $) in Trinidad and Tobago in 2002 to that in 2003?
Provide a succinct answer. 0.81. What is the ratio of the Expenses (in $) in Finland in 2002 to that in 2004?
Your response must be concise. 0.92. What is the ratio of the Expenses (in $) in India in 2002 to that in 2004?
Give a very brief answer. 0.74. What is the ratio of the Expenses (in $) in Russian Federation in 2002 to that in 2004?
Give a very brief answer. 0.55. What is the ratio of the Expenses (in $) of Trinidad and Tobago in 2002 to that in 2004?
Provide a succinct answer. 0.59. What is the ratio of the Expenses (in $) in Finland in 2002 to that in 2005?
Ensure brevity in your answer.  0.88. What is the ratio of the Expenses (in $) of India in 2002 to that in 2005?
Make the answer very short. 0.67. What is the ratio of the Expenses (in $) of Russian Federation in 2002 to that in 2005?
Give a very brief answer. 0.74. What is the ratio of the Expenses (in $) of Trinidad and Tobago in 2002 to that in 2005?
Offer a terse response. 0.46. What is the ratio of the Expenses (in $) of Finland in 2002 to that in 2006?
Your response must be concise. 0.84. What is the ratio of the Expenses (in $) in India in 2002 to that in 2006?
Offer a terse response. 0.64. What is the ratio of the Expenses (in $) of Russian Federation in 2002 to that in 2006?
Give a very brief answer. 0.48. What is the ratio of the Expenses (in $) in Trinidad and Tobago in 2002 to that in 2006?
Provide a succinct answer. 0.37. What is the ratio of the Expenses (in $) of Finland in 2002 to that in 2007?
Make the answer very short. 0.81. What is the ratio of the Expenses (in $) in India in 2002 to that in 2007?
Your answer should be very brief. 0.59. What is the ratio of the Expenses (in $) of Russian Federation in 2002 to that in 2007?
Your answer should be very brief. 0.44. What is the ratio of the Expenses (in $) of Trinidad and Tobago in 2002 to that in 2007?
Keep it short and to the point. 0.35. What is the ratio of the Expenses (in $) of Finland in 2002 to that in 2008?
Keep it short and to the point. 0.75. What is the ratio of the Expenses (in $) in India in 2002 to that in 2008?
Ensure brevity in your answer.  0.5. What is the ratio of the Expenses (in $) in Russian Federation in 2002 to that in 2008?
Provide a succinct answer. 0.38. What is the ratio of the Expenses (in $) of Trinidad and Tobago in 2002 to that in 2008?
Ensure brevity in your answer.  0.31. What is the ratio of the Expenses (in $) of Finland in 2002 to that in 2009?
Provide a short and direct response. 0.72. What is the ratio of the Expenses (in $) of India in 2002 to that in 2009?
Keep it short and to the point. 0.48. What is the ratio of the Expenses (in $) in Russian Federation in 2002 to that in 2009?
Make the answer very short. 0.33. What is the ratio of the Expenses (in $) in Trinidad and Tobago in 2002 to that in 2009?
Offer a terse response. 0.27. What is the ratio of the Expenses (in $) in Finland in 2003 to that in 2004?
Provide a succinct answer. 0.95. What is the ratio of the Expenses (in $) of India in 2003 to that in 2004?
Make the answer very short. 0.76. What is the ratio of the Expenses (in $) in Russian Federation in 2003 to that in 2004?
Your answer should be compact. 0.69. What is the ratio of the Expenses (in $) in Trinidad and Tobago in 2003 to that in 2004?
Ensure brevity in your answer.  0.72. What is the ratio of the Expenses (in $) of Finland in 2003 to that in 2005?
Make the answer very short. 0.91. What is the ratio of the Expenses (in $) of India in 2003 to that in 2005?
Ensure brevity in your answer.  0.69. What is the ratio of the Expenses (in $) in Russian Federation in 2003 to that in 2005?
Offer a very short reply. 0.93. What is the ratio of the Expenses (in $) in Trinidad and Tobago in 2003 to that in 2005?
Your answer should be compact. 0.57. What is the ratio of the Expenses (in $) of Finland in 2003 to that in 2006?
Your response must be concise. 0.88. What is the ratio of the Expenses (in $) of India in 2003 to that in 2006?
Ensure brevity in your answer.  0.66. What is the ratio of the Expenses (in $) of Russian Federation in 2003 to that in 2006?
Provide a short and direct response. 0.6. What is the ratio of the Expenses (in $) of Trinidad and Tobago in 2003 to that in 2006?
Make the answer very short. 0.46. What is the ratio of the Expenses (in $) of Finland in 2003 to that in 2007?
Give a very brief answer. 0.85. What is the ratio of the Expenses (in $) of India in 2003 to that in 2007?
Keep it short and to the point. 0.61. What is the ratio of the Expenses (in $) in Russian Federation in 2003 to that in 2007?
Ensure brevity in your answer.  0.56. What is the ratio of the Expenses (in $) in Trinidad and Tobago in 2003 to that in 2007?
Your answer should be compact. 0.43. What is the ratio of the Expenses (in $) in Finland in 2003 to that in 2008?
Provide a short and direct response. 0.78. What is the ratio of the Expenses (in $) of India in 2003 to that in 2008?
Give a very brief answer. 0.52. What is the ratio of the Expenses (in $) in Russian Federation in 2003 to that in 2008?
Your response must be concise. 0.47. What is the ratio of the Expenses (in $) in Trinidad and Tobago in 2003 to that in 2008?
Make the answer very short. 0.39. What is the ratio of the Expenses (in $) in Finland in 2003 to that in 2009?
Your answer should be very brief. 0.74. What is the ratio of the Expenses (in $) in India in 2003 to that in 2009?
Ensure brevity in your answer.  0.5. What is the ratio of the Expenses (in $) in Russian Federation in 2003 to that in 2009?
Make the answer very short. 0.41. What is the ratio of the Expenses (in $) in Trinidad and Tobago in 2003 to that in 2009?
Make the answer very short. 0.33. What is the ratio of the Expenses (in $) of Finland in 2004 to that in 2005?
Give a very brief answer. 0.96. What is the ratio of the Expenses (in $) in India in 2004 to that in 2005?
Provide a short and direct response. 0.9. What is the ratio of the Expenses (in $) in Russian Federation in 2004 to that in 2005?
Your answer should be very brief. 1.36. What is the ratio of the Expenses (in $) in Trinidad and Tobago in 2004 to that in 2005?
Keep it short and to the point. 0.79. What is the ratio of the Expenses (in $) of Finland in 2004 to that in 2006?
Ensure brevity in your answer.  0.92. What is the ratio of the Expenses (in $) in India in 2004 to that in 2006?
Your answer should be compact. 0.87. What is the ratio of the Expenses (in $) of Russian Federation in 2004 to that in 2006?
Offer a very short reply. 0.87. What is the ratio of the Expenses (in $) of Trinidad and Tobago in 2004 to that in 2006?
Provide a succinct answer. 0.63. What is the ratio of the Expenses (in $) of Finland in 2004 to that in 2007?
Provide a short and direct response. 0.89. What is the ratio of the Expenses (in $) in India in 2004 to that in 2007?
Give a very brief answer. 0.8. What is the ratio of the Expenses (in $) in Russian Federation in 2004 to that in 2007?
Your answer should be very brief. 0.81. What is the ratio of the Expenses (in $) in Trinidad and Tobago in 2004 to that in 2007?
Your response must be concise. 0.6. What is the ratio of the Expenses (in $) in Finland in 2004 to that in 2008?
Keep it short and to the point. 0.82. What is the ratio of the Expenses (in $) in India in 2004 to that in 2008?
Your response must be concise. 0.68. What is the ratio of the Expenses (in $) in Russian Federation in 2004 to that in 2008?
Your answer should be very brief. 0.69. What is the ratio of the Expenses (in $) of Trinidad and Tobago in 2004 to that in 2008?
Offer a very short reply. 0.54. What is the ratio of the Expenses (in $) in Finland in 2004 to that in 2009?
Offer a terse response. 0.78. What is the ratio of the Expenses (in $) in India in 2004 to that in 2009?
Make the answer very short. 0.65. What is the ratio of the Expenses (in $) in Russian Federation in 2004 to that in 2009?
Provide a succinct answer. 0.6. What is the ratio of the Expenses (in $) of Trinidad and Tobago in 2004 to that in 2009?
Ensure brevity in your answer.  0.46. What is the ratio of the Expenses (in $) in Finland in 2005 to that in 2006?
Ensure brevity in your answer.  0.96. What is the ratio of the Expenses (in $) of India in 2005 to that in 2006?
Your answer should be very brief. 0.97. What is the ratio of the Expenses (in $) in Russian Federation in 2005 to that in 2006?
Offer a very short reply. 0.64. What is the ratio of the Expenses (in $) of Trinidad and Tobago in 2005 to that in 2006?
Provide a succinct answer. 0.8. What is the ratio of the Expenses (in $) in Finland in 2005 to that in 2007?
Provide a succinct answer. 0.93. What is the ratio of the Expenses (in $) of Russian Federation in 2005 to that in 2007?
Your answer should be very brief. 0.6. What is the ratio of the Expenses (in $) in Trinidad and Tobago in 2005 to that in 2007?
Your answer should be compact. 0.76. What is the ratio of the Expenses (in $) in Finland in 2005 to that in 2008?
Provide a short and direct response. 0.86. What is the ratio of the Expenses (in $) of India in 2005 to that in 2008?
Ensure brevity in your answer.  0.75. What is the ratio of the Expenses (in $) in Russian Federation in 2005 to that in 2008?
Your response must be concise. 0.51. What is the ratio of the Expenses (in $) in Trinidad and Tobago in 2005 to that in 2008?
Keep it short and to the point. 0.68. What is the ratio of the Expenses (in $) of Finland in 2005 to that in 2009?
Give a very brief answer. 0.82. What is the ratio of the Expenses (in $) in India in 2005 to that in 2009?
Your answer should be very brief. 0.72. What is the ratio of the Expenses (in $) in Russian Federation in 2005 to that in 2009?
Your answer should be very brief. 0.44. What is the ratio of the Expenses (in $) in Trinidad and Tobago in 2005 to that in 2009?
Provide a short and direct response. 0.58. What is the ratio of the Expenses (in $) of India in 2006 to that in 2007?
Make the answer very short. 0.92. What is the ratio of the Expenses (in $) of Russian Federation in 2006 to that in 2007?
Provide a short and direct response. 0.93. What is the ratio of the Expenses (in $) of Trinidad and Tobago in 2006 to that in 2007?
Your answer should be very brief. 0.95. What is the ratio of the Expenses (in $) in Finland in 2006 to that in 2008?
Offer a very short reply. 0.89. What is the ratio of the Expenses (in $) of India in 2006 to that in 2008?
Offer a terse response. 0.78. What is the ratio of the Expenses (in $) in Russian Federation in 2006 to that in 2008?
Keep it short and to the point. 0.79. What is the ratio of the Expenses (in $) of Trinidad and Tobago in 2006 to that in 2008?
Keep it short and to the point. 0.85. What is the ratio of the Expenses (in $) of Finland in 2006 to that in 2009?
Offer a very short reply. 0.85. What is the ratio of the Expenses (in $) in India in 2006 to that in 2009?
Your answer should be very brief. 0.75. What is the ratio of the Expenses (in $) of Russian Federation in 2006 to that in 2009?
Your answer should be compact. 0.69. What is the ratio of the Expenses (in $) in Trinidad and Tobago in 2006 to that in 2009?
Give a very brief answer. 0.72. What is the ratio of the Expenses (in $) of Finland in 2007 to that in 2008?
Ensure brevity in your answer.  0.92. What is the ratio of the Expenses (in $) in India in 2007 to that in 2008?
Ensure brevity in your answer.  0.85. What is the ratio of the Expenses (in $) in Russian Federation in 2007 to that in 2008?
Offer a terse response. 0.85. What is the ratio of the Expenses (in $) in Trinidad and Tobago in 2007 to that in 2008?
Offer a very short reply. 0.9. What is the ratio of the Expenses (in $) of India in 2007 to that in 2009?
Keep it short and to the point. 0.81. What is the ratio of the Expenses (in $) of Russian Federation in 2007 to that in 2009?
Keep it short and to the point. 0.74. What is the ratio of the Expenses (in $) of Trinidad and Tobago in 2007 to that in 2009?
Provide a short and direct response. 0.76. What is the ratio of the Expenses (in $) in Finland in 2008 to that in 2009?
Give a very brief answer. 0.95. What is the ratio of the Expenses (in $) of India in 2008 to that in 2009?
Your answer should be very brief. 0.96. What is the ratio of the Expenses (in $) in Russian Federation in 2008 to that in 2009?
Give a very brief answer. 0.87. What is the ratio of the Expenses (in $) of Trinidad and Tobago in 2008 to that in 2009?
Your answer should be very brief. 0.85. What is the difference between the highest and the second highest Expenses (in $) of Finland?
Provide a short and direct response. 3.42e+08. What is the difference between the highest and the second highest Expenses (in $) in India?
Give a very brief answer. 3.78e+1. What is the difference between the highest and the second highest Expenses (in $) of Russian Federation?
Provide a short and direct response. 1.89e+11. What is the difference between the highest and the second highest Expenses (in $) of Trinidad and Tobago?
Give a very brief answer. 1.12e+09. What is the difference between the highest and the lowest Expenses (in $) of Finland?
Offer a very short reply. 2.01e+09. What is the difference between the highest and the lowest Expenses (in $) of India?
Provide a short and direct response. 5.00e+11. What is the difference between the highest and the lowest Expenses (in $) of Russian Federation?
Offer a very short reply. 9.54e+11. What is the difference between the highest and the lowest Expenses (in $) of Trinidad and Tobago?
Your response must be concise. 5.48e+09. 